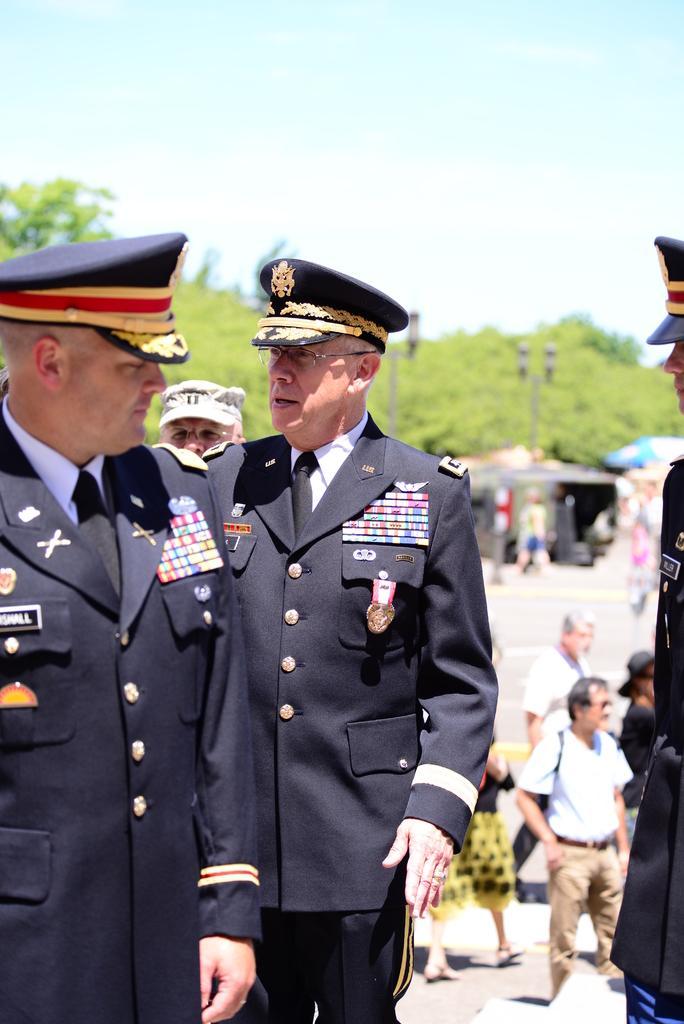Could you give a brief overview of what you see in this image? In the background We can see the sky and it seems like a sunny day. In this picture we can see trees, poles and we can see people on the road. This picture is mainly highlighted with men wearing uniform and they are standing. 